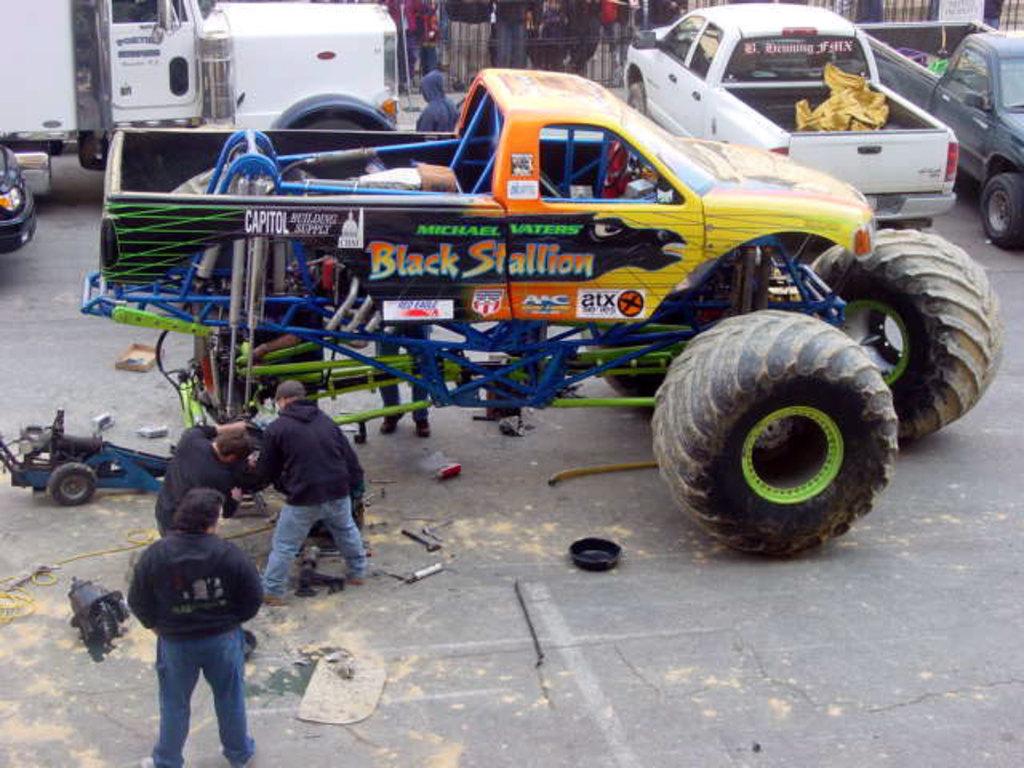What's the name of this monster truck?
Give a very brief answer. Black stallion. 